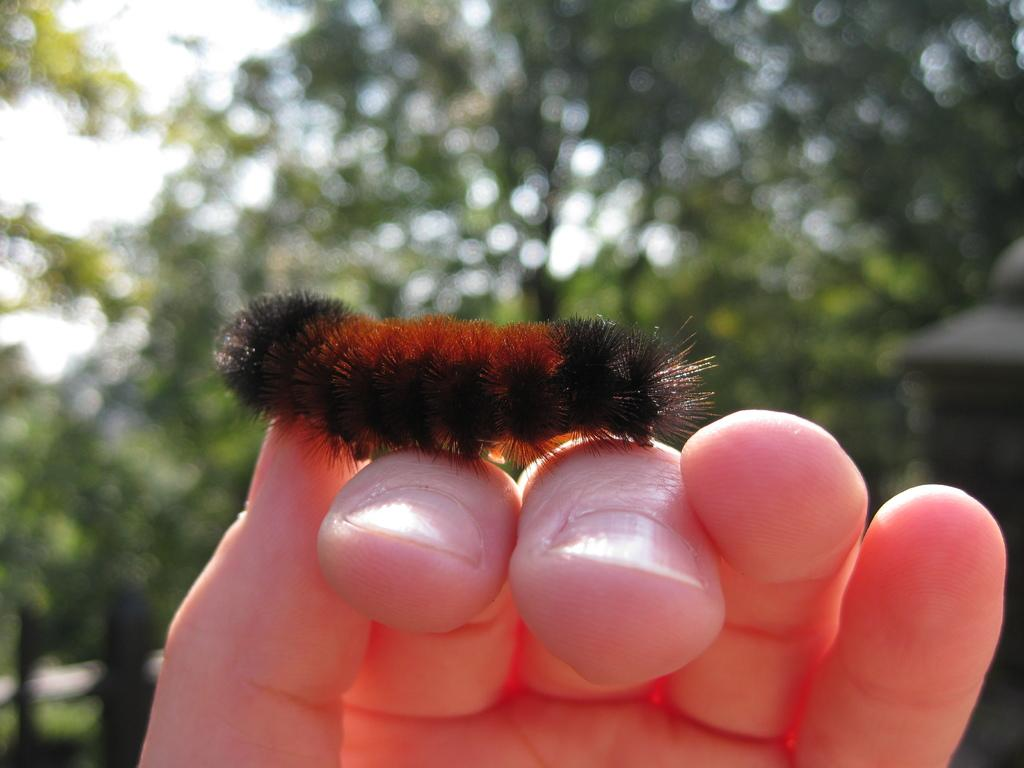What is on the person's hand in the image? There is an insect on the person's hand in the image. What can be seen in the distance behind the person? There are trees in the background of the image. What is visible above the trees in the image? The sky is visible in the background of the image. How would you describe the focus of the image? The background appears blurry in the image. What type of silk is being spun by the horn on the person's hand in the image? There is no silk or horn present in the image; it features an insect on a person's hand. What order of insects can be seen in the image? The specific order of insects cannot be determined from the image, as it only shows a general insect on a person's hand. 